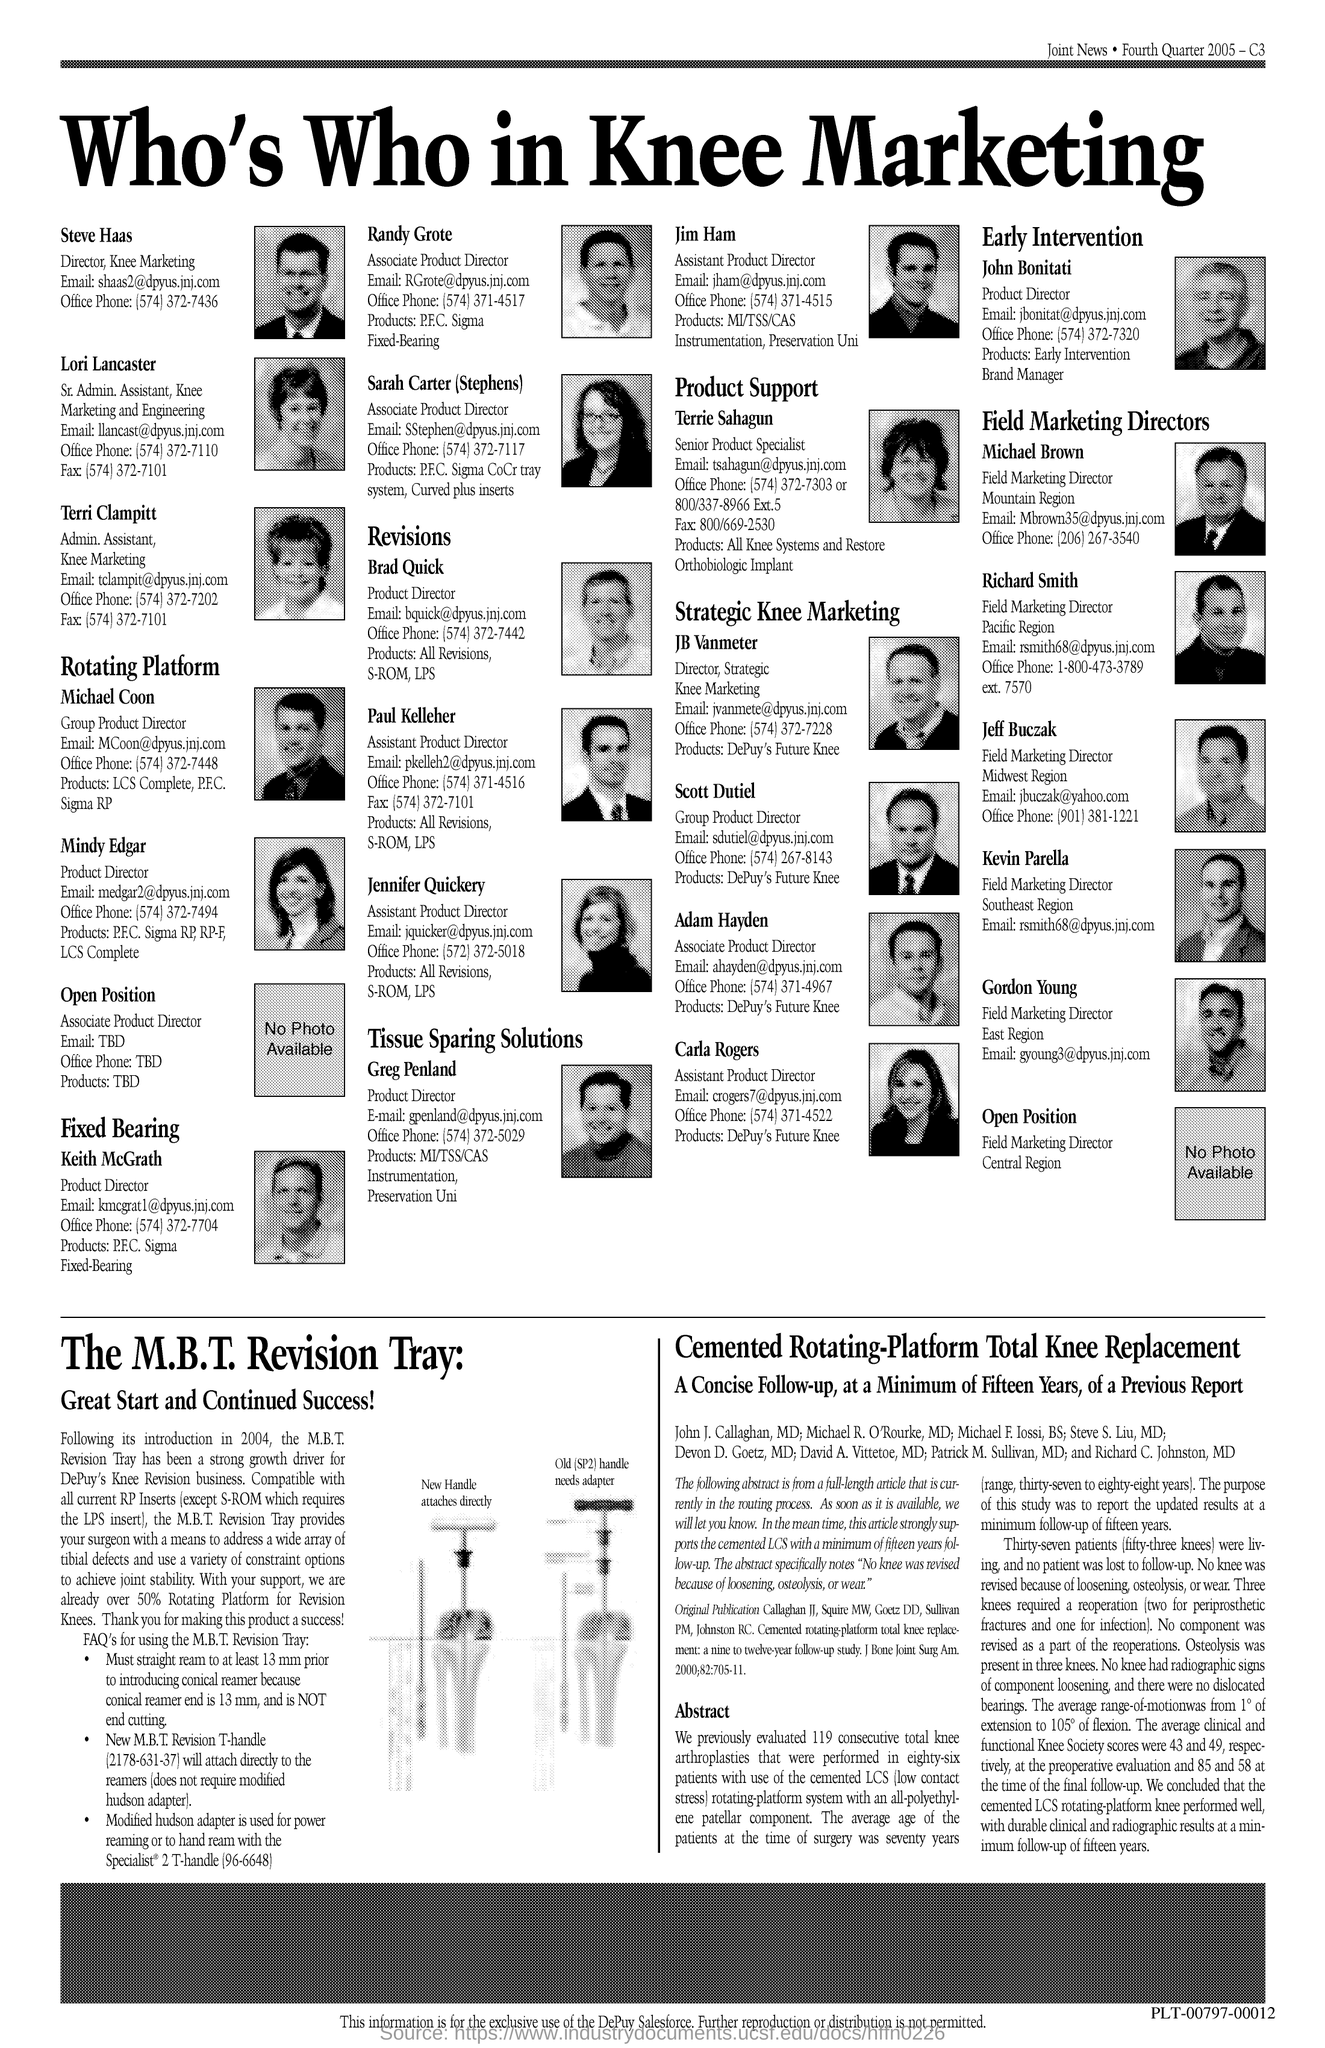Mention a couple of crucial points in this snapshot. The Admin. Assistant at Knee Marketing is named Terri Clampitt. The Director at Knee Marketing is named Steve Haas. Richard Smith is the Field Marketing Director. 